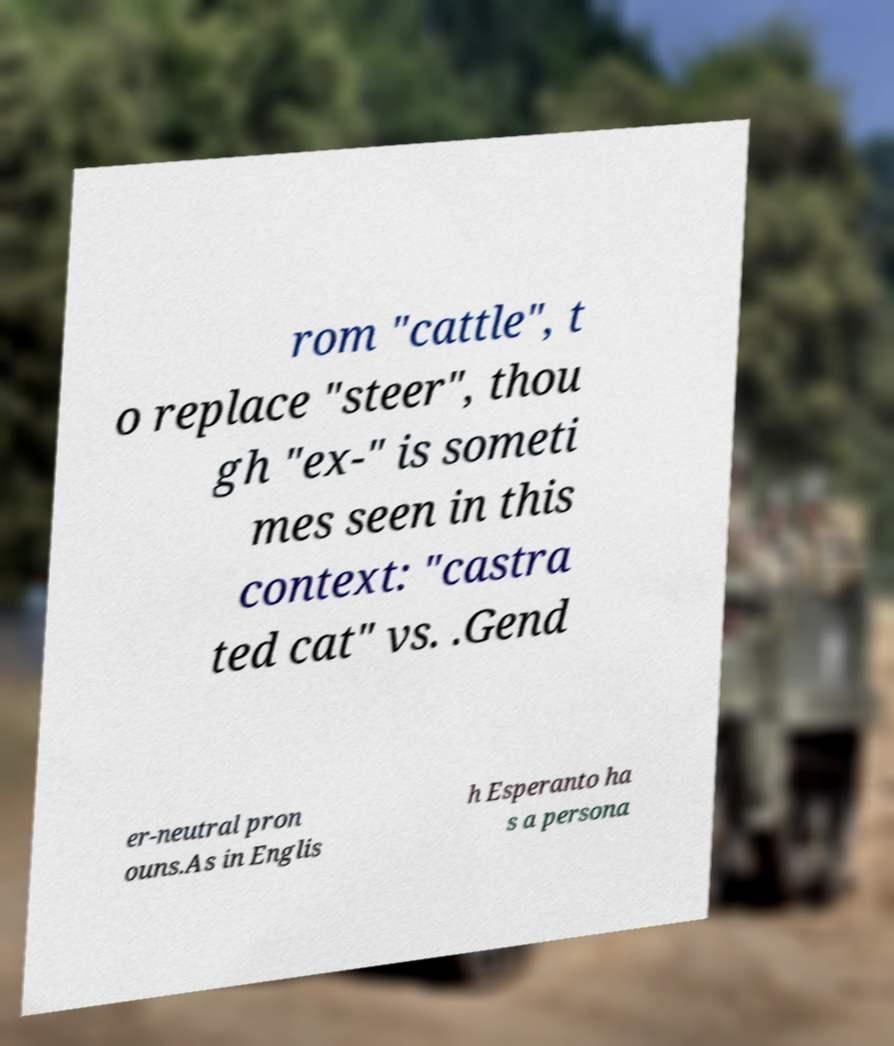Could you assist in decoding the text presented in this image and type it out clearly? rom "cattle", t o replace "steer", thou gh "ex-" is someti mes seen in this context: "castra ted cat" vs. .Gend er-neutral pron ouns.As in Englis h Esperanto ha s a persona 